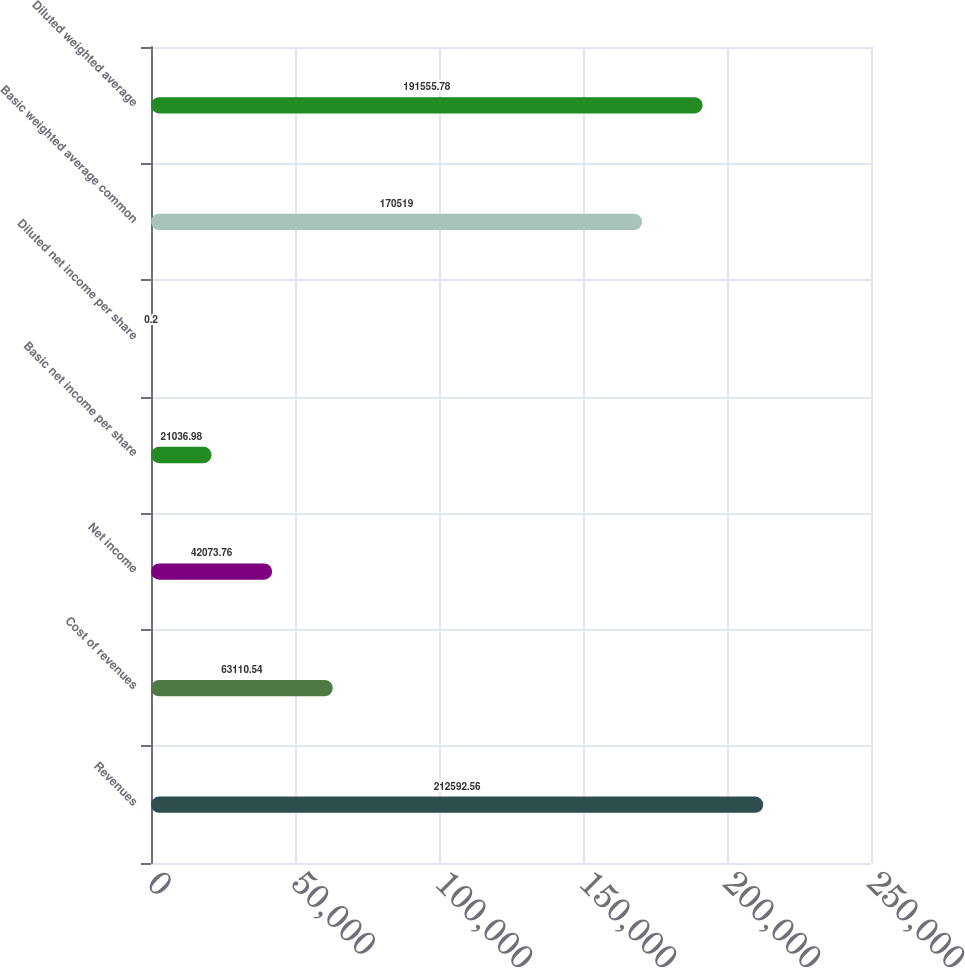<chart> <loc_0><loc_0><loc_500><loc_500><bar_chart><fcel>Revenues<fcel>Cost of revenues<fcel>Net income<fcel>Basic net income per share<fcel>Diluted net income per share<fcel>Basic weighted average common<fcel>Diluted weighted average<nl><fcel>212593<fcel>63110.5<fcel>42073.8<fcel>21037<fcel>0.2<fcel>170519<fcel>191556<nl></chart> 